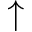Convert formula to latex. <formula><loc_0><loc_0><loc_500><loc_500>\uparrow</formula> 